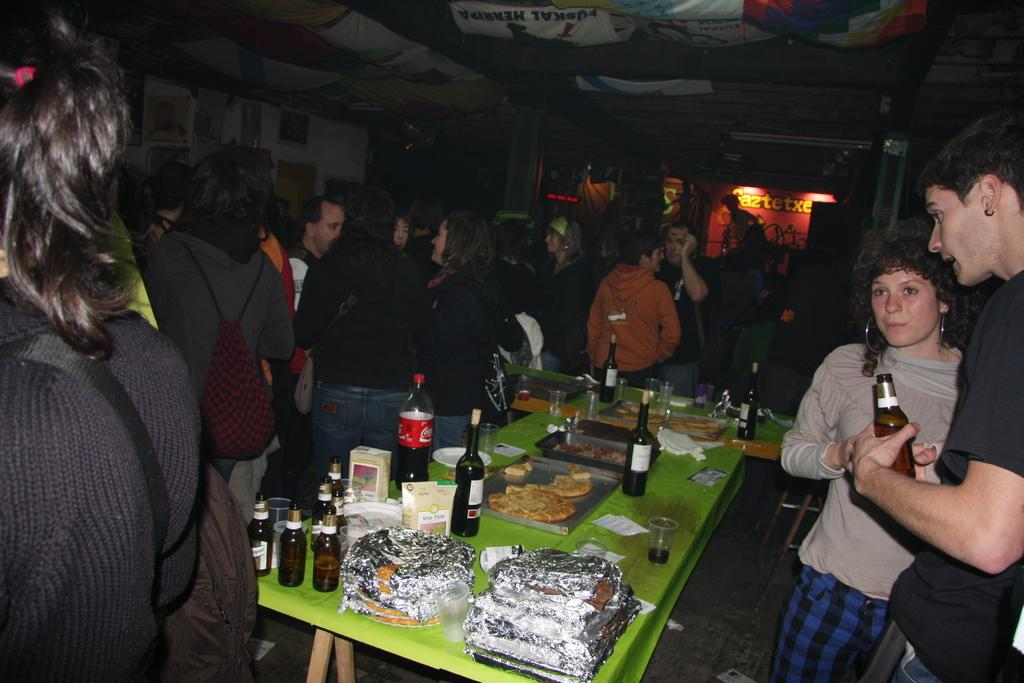What can be seen in the image involving people? There are persons standing in the image. What objects are present that might be used for holding or serving liquids? There are bottles and glasses in the image. What objects are present that might be used for serving or eating food? There are plates in the image, along with other food items. What type of furniture is visible in the image? A: There is a table in the image. What can be seen in the background of the image? There is a wall in the background of the image. How many dogs are playing with a sock in the image? There are no dogs or socks present in the image. What type of machine is visible in the background of the image? There is no machine visible in the background of the image; only a wall is present. 